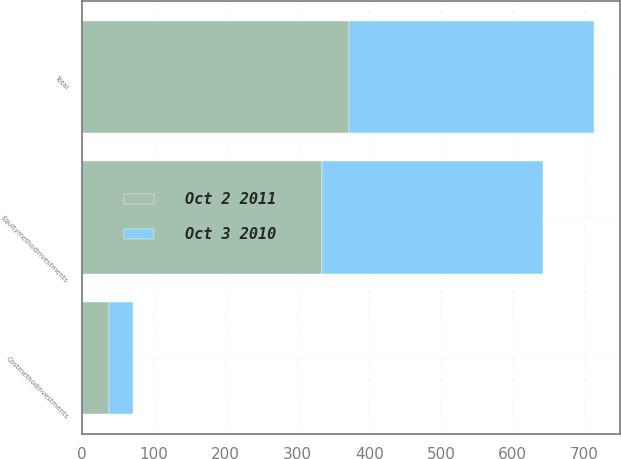Convert chart. <chart><loc_0><loc_0><loc_500><loc_500><stacked_bar_chart><ecel><fcel>Equitymethodinvestments<fcel>Costmethodinvestments<fcel>Total<nl><fcel>Oct 2 2011<fcel>334.4<fcel>37.9<fcel>372.3<nl><fcel>Oct 3 2010<fcel>308.1<fcel>33.4<fcel>341.5<nl></chart> 